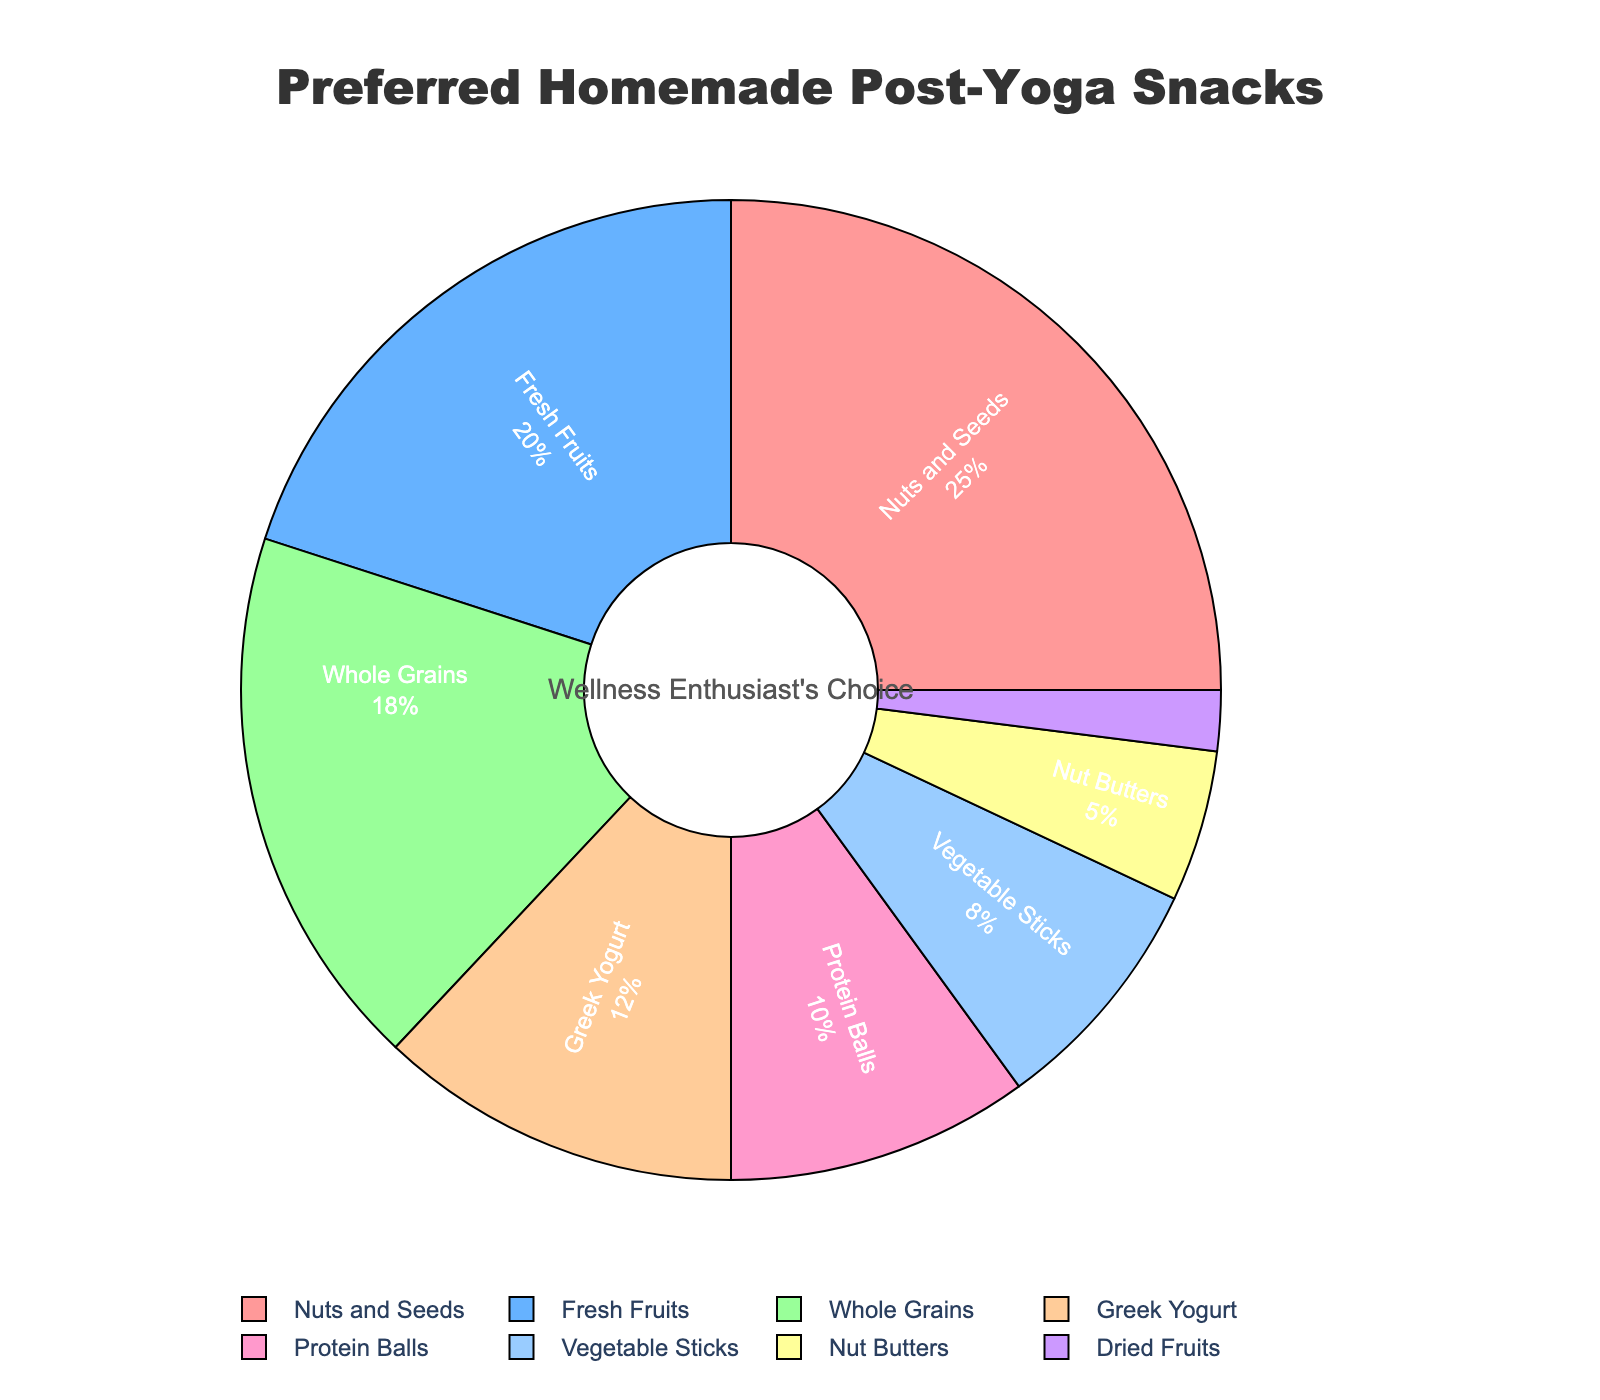What's the most preferred homemade post-yoga snack? The most preferred snack would have the largest percentage in the pie chart. Nuts and Seeds have the highest percentage at 25%.
Answer: Nuts and Seeds What percentage of preferred snacks are fresh fruits and vegetable sticks combined? Add the percentages of Fresh Fruits (20%) and Vegetable Sticks (8%) together: 20 + 8 = 28%
Answer: 28% Which ingredient type is least preferred as a post-yoga snack? The least preferred snack would have the smallest percentage in the pie chart. Dried Fruits have the lowest percentage at 2%.
Answer: Dried Fruits What is the difference in percentage between the most and least preferred snacks? Subtract the percentage of the least preferred snack (Dried Fruits, 2%) from the most preferred snack (Nuts and Seeds, 25%): 25 - 2 = 23%
Answer: 23% How do the preferences for Greek Yogurt and Protein Balls compare? Greek Yogurt has a percentage of 12% and Protein Balls have a percentage of 10%. Greek Yogurt is preferred slightly more than Protein Balls.
Answer: Greek Yogurt is preferred more What percentage of the preferred snacks is made up of nuts and seeds, whole grains, and nut butters combined? Add the percentages for Nuts and Seeds (25%), Whole Grains (18%), and Nut Butters (5%): 25 + 18 + 5 = 48%
Answer: 48% Are fresh fruits preferred more than whole grains? Compare the percentages: Fresh Fruits (20%) is greater than Whole Grains (18%).
Answer: Yes Which is the second least preferred snack? Identify the snack with the second smallest percentage. Nut Butters have the next lowest percentage after Dried Fruits, at 5%.
Answer: Nut Butters Is the percentage for Protein Balls more than half of the percentage for Nuts and Seeds? Calculate half of the Nuts and Seeds percentage: 25 / 2 = 12.5%. The percentage for Protein Balls is 10%, which is less than 12.5%.
Answer: No What are the total percentages of all snack preferences shown in the pie chart? Sum all the percentages provided in the data: 25 + 20 + 18 + 12 + 10 + 8 + 5 + 2 = 100%
Answer: 100% 